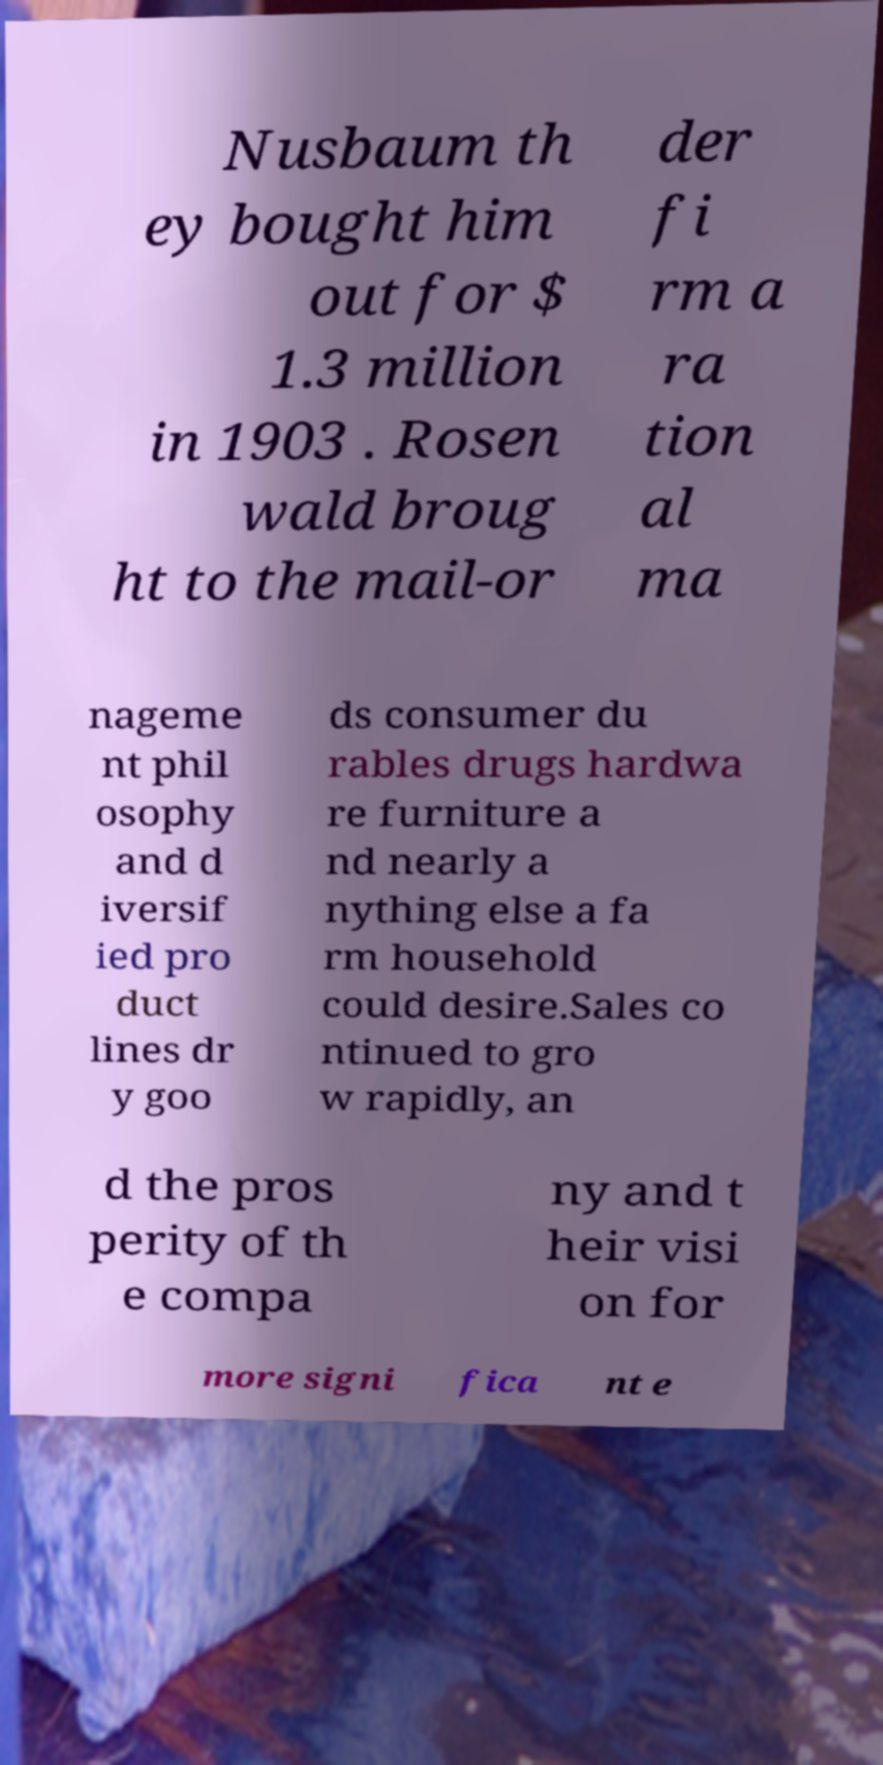For documentation purposes, I need the text within this image transcribed. Could you provide that? Nusbaum th ey bought him out for $ 1.3 million in 1903 . Rosen wald broug ht to the mail-or der fi rm a ra tion al ma nageme nt phil osophy and d iversif ied pro duct lines dr y goo ds consumer du rables drugs hardwa re furniture a nd nearly a nything else a fa rm household could desire.Sales co ntinued to gro w rapidly, an d the pros perity of th e compa ny and t heir visi on for more signi fica nt e 